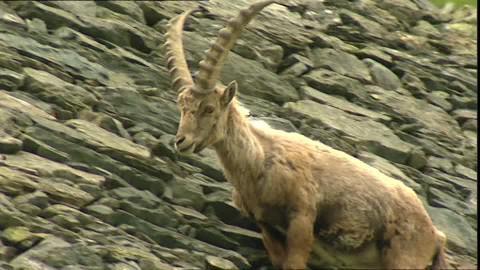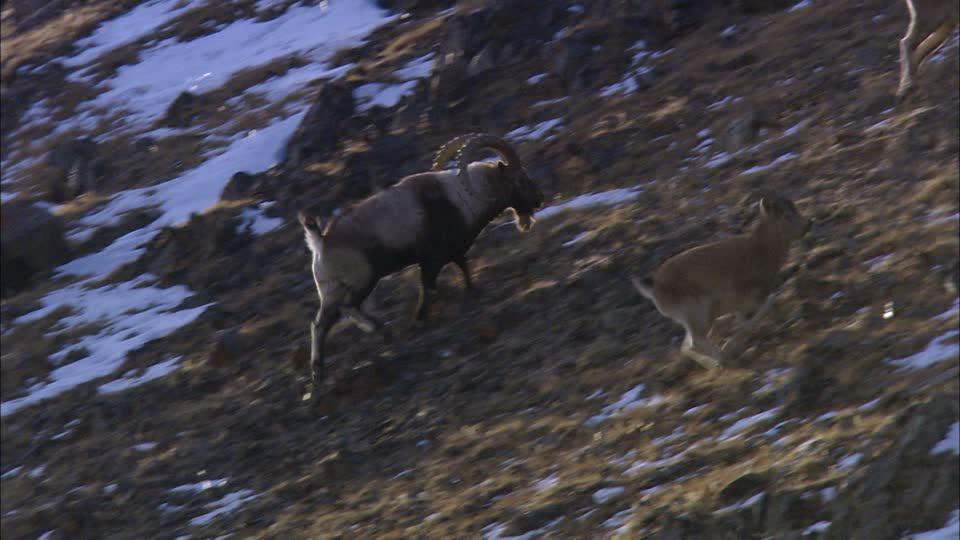The first image is the image on the left, the second image is the image on the right. For the images shown, is this caption "One of the images features a mountain goat descending a grassy hill." true? Answer yes or no. No. The first image is the image on the left, the second image is the image on the right. For the images displayed, is the sentence "There is snow on the ground in the right image." factually correct? Answer yes or no. Yes. 